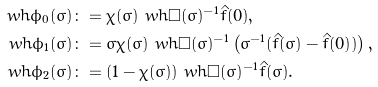<formula> <loc_0><loc_0><loc_500><loc_500>\ w h { \phi _ { 0 } } ( \sigma ) & \colon = \chi ( \sigma ) \ w h \Box ( \sigma ) ^ { - 1 } \hat { f } ( 0 ) , \\ \ w h { \phi _ { 1 } } ( \sigma ) & \colon = \sigma \chi ( \sigma ) \ w h \Box ( \sigma ) ^ { - 1 } \left ( \sigma ^ { - 1 } ( \hat { f } ( \sigma ) - \hat { f } ( 0 ) ) \right ) , \\ \ w h { \phi _ { 2 } } ( \sigma ) & \colon = ( 1 - \chi ( \sigma ) ) \ w h \Box ( \sigma ) ^ { - 1 } \hat { f } ( \sigma ) .</formula> 